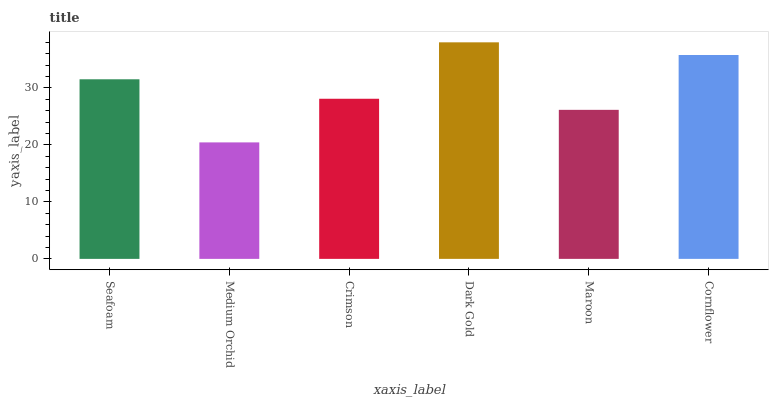Is Medium Orchid the minimum?
Answer yes or no. Yes. Is Dark Gold the maximum?
Answer yes or no. Yes. Is Crimson the minimum?
Answer yes or no. No. Is Crimson the maximum?
Answer yes or no. No. Is Crimson greater than Medium Orchid?
Answer yes or no. Yes. Is Medium Orchid less than Crimson?
Answer yes or no. Yes. Is Medium Orchid greater than Crimson?
Answer yes or no. No. Is Crimson less than Medium Orchid?
Answer yes or no. No. Is Seafoam the high median?
Answer yes or no. Yes. Is Crimson the low median?
Answer yes or no. Yes. Is Cornflower the high median?
Answer yes or no. No. Is Medium Orchid the low median?
Answer yes or no. No. 